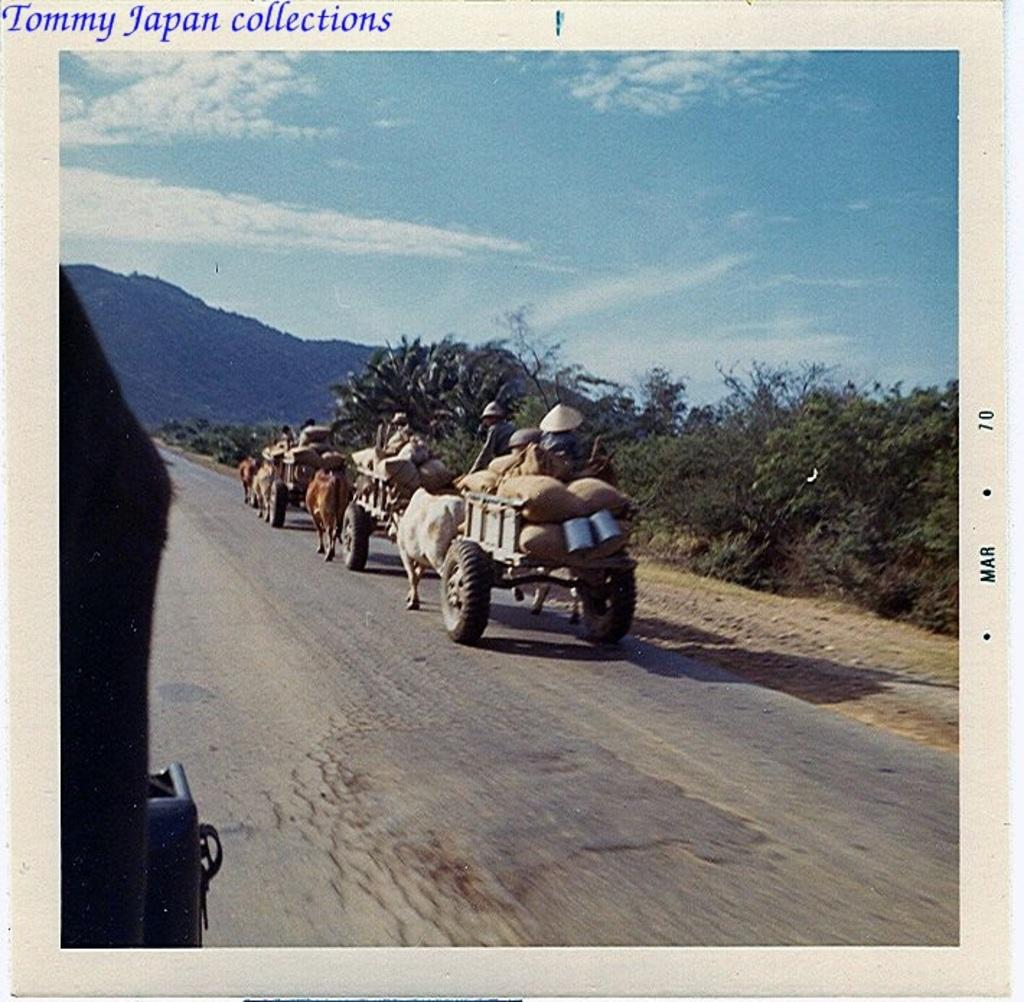Where was the image taken? The image was clicked outside. What can be seen in the middle of the image? There are trees and carts in the middle of the image. What is visible at the top of the image? The sky is visible at the top of the image. What is the value of the cough in the image? There is no cough present in the image, so it is not possible to determine its value. 